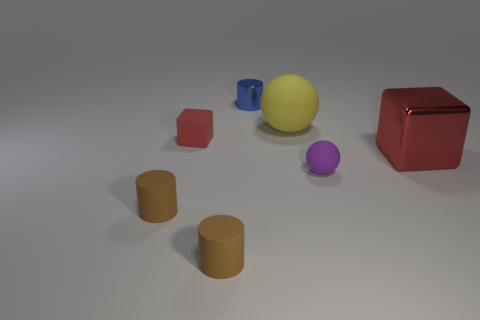There is a cube left of the tiny blue shiny cylinder; is it the same size as the rubber sphere behind the purple rubber sphere?
Ensure brevity in your answer.  No. Are there fewer purple rubber objects on the left side of the blue cylinder than small brown things in front of the small matte block?
Your answer should be very brief. Yes. What material is the big thing that is the same color as the tiny rubber block?
Give a very brief answer. Metal. There is a tiny object behind the small matte block; what color is it?
Give a very brief answer. Blue. Does the large metal block have the same color as the tiny matte cube?
Your answer should be compact. Yes. There is a shiny thing that is behind the matte object behind the red matte block; what number of large yellow spheres are to the right of it?
Keep it short and to the point. 1. The red matte object is what size?
Your response must be concise. Small. There is a ball that is the same size as the red matte object; what material is it?
Keep it short and to the point. Rubber. What number of big red things are right of the small purple object?
Offer a very short reply. 1. Is the material of the cylinder that is behind the tiny red matte block the same as the red cube to the right of the tiny blue metal thing?
Provide a succinct answer. Yes. 